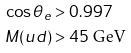<formula> <loc_0><loc_0><loc_500><loc_500>\cos \theta _ { e } & > 0 . 9 9 7 \\ M ( u d ) & > 4 5 \text { GeV}</formula> 